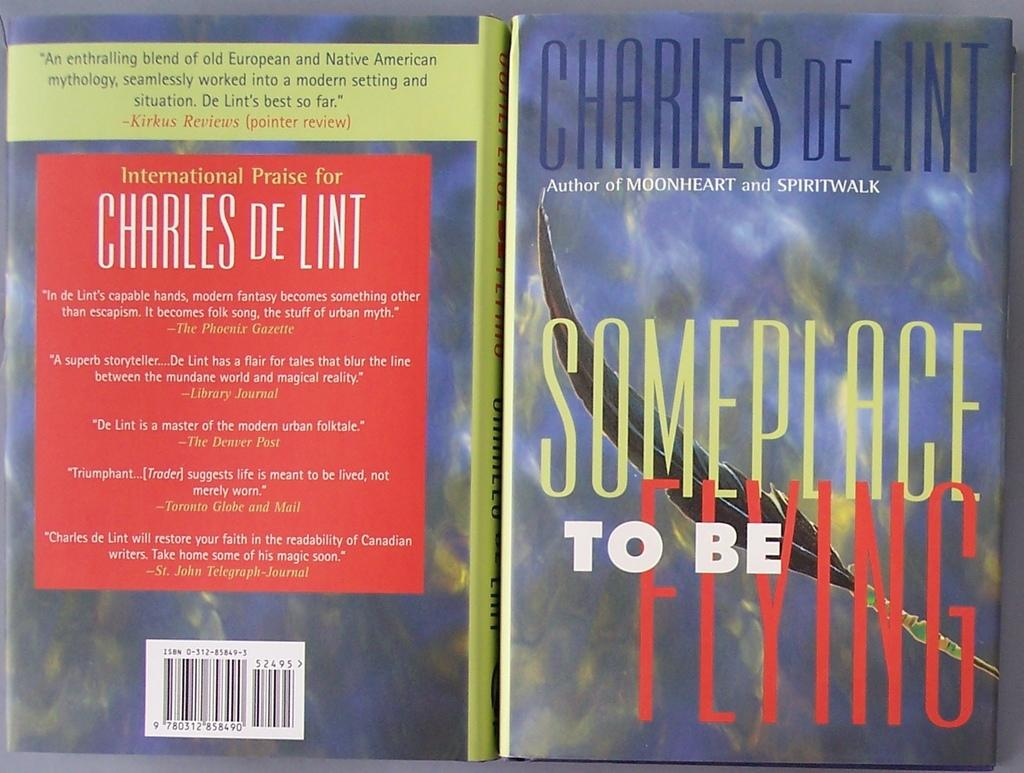<image>
Offer a succinct explanation of the picture presented. A book by Charles De Lint is open showing the front and back cover. 